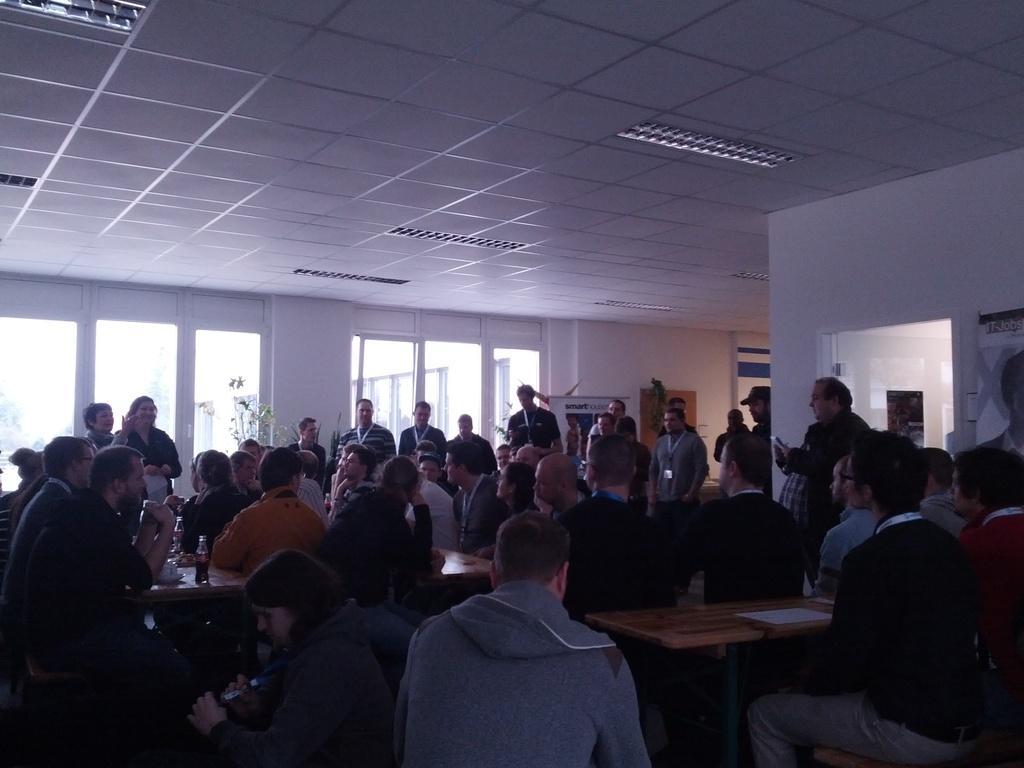Could you give a brief overview of what you see in this image? In this image I can see some people. I can see the table. At the top I can see the white roof. 